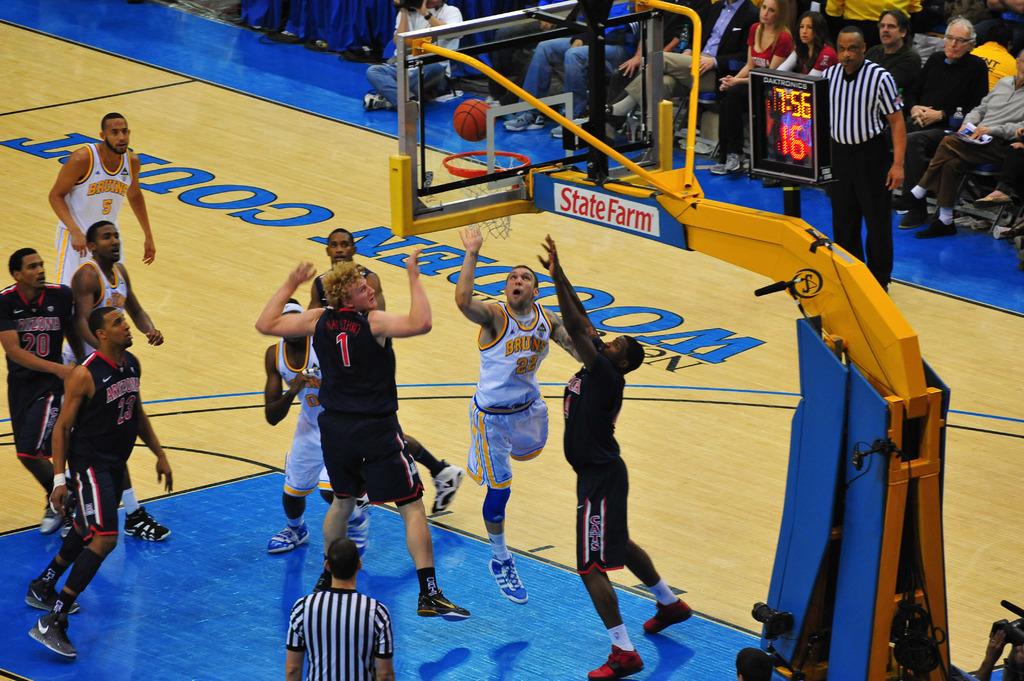What is the name of the sponsor on the basket?
Provide a short and direct response. State farm. 